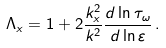Convert formula to latex. <formula><loc_0><loc_0><loc_500><loc_500>\Lambda _ { x } = 1 + 2 \frac { k _ { x } ^ { 2 } } { k ^ { 2 } } \frac { d \ln { \tau _ { \omega } } } { d \ln { \varepsilon } } \, .</formula> 